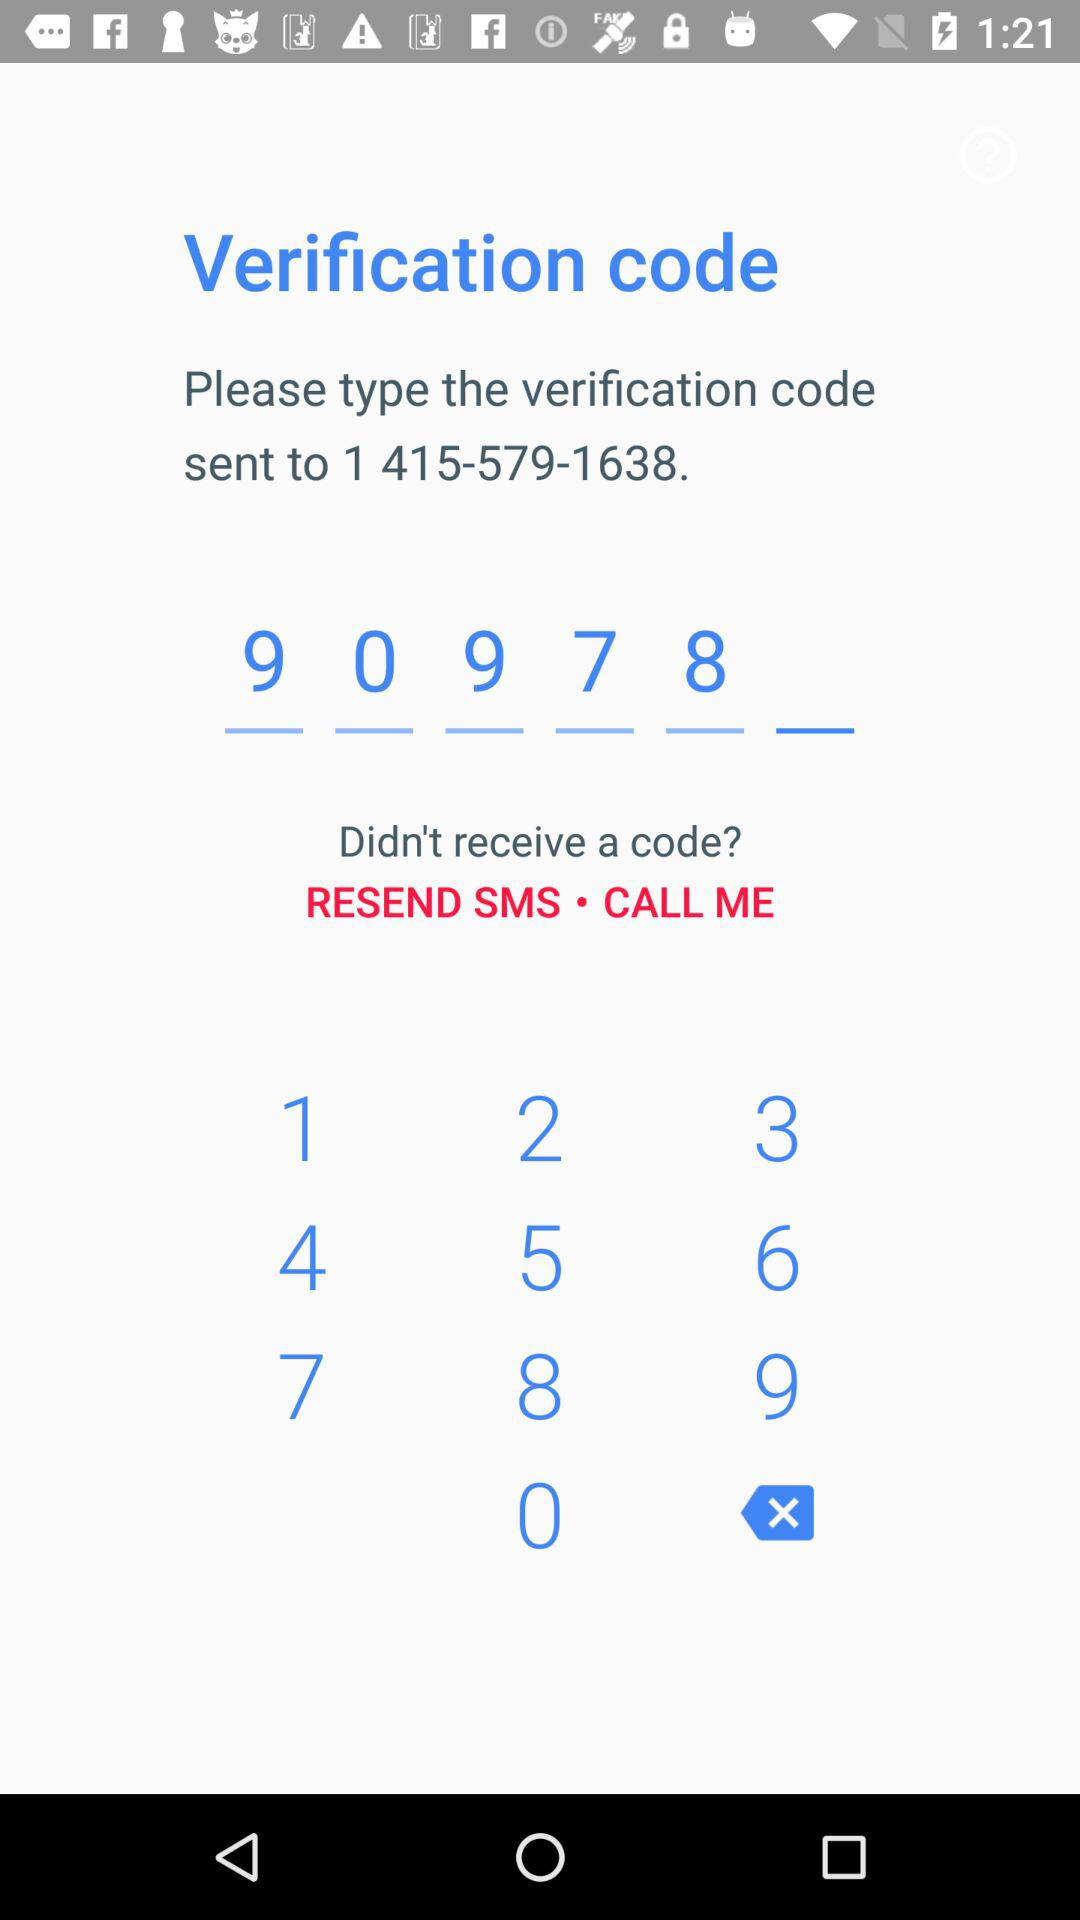What is the verification code? The verification code is "90978". 